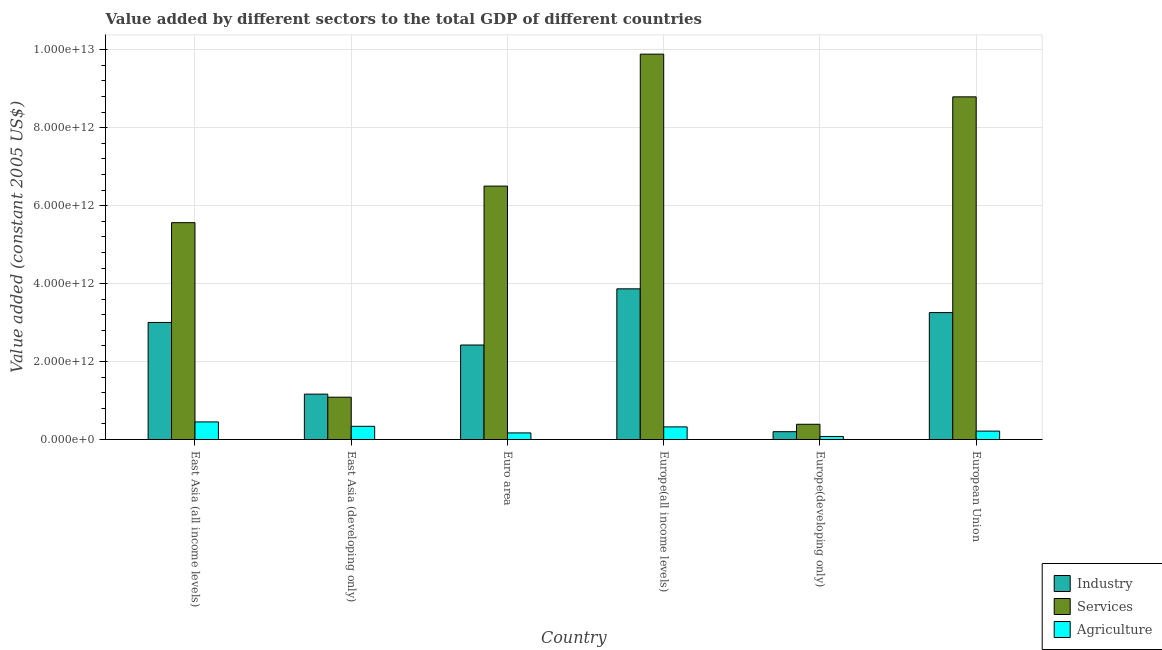How many different coloured bars are there?
Your response must be concise. 3. Are the number of bars on each tick of the X-axis equal?
Provide a succinct answer. Yes. How many bars are there on the 4th tick from the left?
Provide a succinct answer. 3. What is the label of the 5th group of bars from the left?
Give a very brief answer. Europe(developing only). What is the value added by industrial sector in Europe(developing only)?
Offer a terse response. 2.01e+11. Across all countries, what is the maximum value added by services?
Offer a terse response. 9.89e+12. Across all countries, what is the minimum value added by industrial sector?
Provide a succinct answer. 2.01e+11. In which country was the value added by industrial sector maximum?
Offer a very short reply. Europe(all income levels). In which country was the value added by agricultural sector minimum?
Provide a short and direct response. Europe(developing only). What is the total value added by industrial sector in the graph?
Offer a very short reply. 1.39e+13. What is the difference between the value added by agricultural sector in East Asia (all income levels) and that in European Union?
Provide a short and direct response. 2.35e+11. What is the difference between the value added by industrial sector in European Union and the value added by agricultural sector in East Asia (developing only)?
Offer a very short reply. 2.92e+12. What is the average value added by industrial sector per country?
Your answer should be compact. 2.32e+12. What is the difference between the value added by agricultural sector and value added by services in Europe(all income levels)?
Your response must be concise. -9.56e+12. In how many countries, is the value added by services greater than 7200000000000 US$?
Give a very brief answer. 2. What is the ratio of the value added by services in East Asia (developing only) to that in Euro area?
Your answer should be compact. 0.17. Is the value added by services in Euro area less than that in Europe(developing only)?
Your answer should be compact. No. Is the difference between the value added by services in Europe(developing only) and European Union greater than the difference between the value added by agricultural sector in Europe(developing only) and European Union?
Make the answer very short. No. What is the difference between the highest and the second highest value added by services?
Provide a short and direct response. 1.10e+12. What is the difference between the highest and the lowest value added by services?
Your answer should be very brief. 9.50e+12. Is the sum of the value added by services in East Asia (all income levels) and European Union greater than the maximum value added by industrial sector across all countries?
Offer a very short reply. Yes. What does the 3rd bar from the left in Europe(all income levels) represents?
Offer a very short reply. Agriculture. What does the 2nd bar from the right in Euro area represents?
Ensure brevity in your answer.  Services. How many bars are there?
Give a very brief answer. 18. How many countries are there in the graph?
Offer a terse response. 6. What is the difference between two consecutive major ticks on the Y-axis?
Ensure brevity in your answer.  2.00e+12. Does the graph contain grids?
Provide a short and direct response. Yes. How many legend labels are there?
Make the answer very short. 3. How are the legend labels stacked?
Offer a terse response. Vertical. What is the title of the graph?
Provide a succinct answer. Value added by different sectors to the total GDP of different countries. Does "Hydroelectric sources" appear as one of the legend labels in the graph?
Offer a very short reply. No. What is the label or title of the Y-axis?
Make the answer very short. Value added (constant 2005 US$). What is the Value added (constant 2005 US$) in Industry in East Asia (all income levels)?
Provide a short and direct response. 3.00e+12. What is the Value added (constant 2005 US$) of Services in East Asia (all income levels)?
Provide a succinct answer. 5.56e+12. What is the Value added (constant 2005 US$) in Agriculture in East Asia (all income levels)?
Provide a short and direct response. 4.52e+11. What is the Value added (constant 2005 US$) of Industry in East Asia (developing only)?
Provide a short and direct response. 1.16e+12. What is the Value added (constant 2005 US$) of Services in East Asia (developing only)?
Your response must be concise. 1.09e+12. What is the Value added (constant 2005 US$) of Agriculture in East Asia (developing only)?
Make the answer very short. 3.39e+11. What is the Value added (constant 2005 US$) of Industry in Euro area?
Provide a short and direct response. 2.42e+12. What is the Value added (constant 2005 US$) in Services in Euro area?
Offer a very short reply. 6.50e+12. What is the Value added (constant 2005 US$) in Agriculture in Euro area?
Your response must be concise. 1.69e+11. What is the Value added (constant 2005 US$) in Industry in Europe(all income levels)?
Provide a short and direct response. 3.87e+12. What is the Value added (constant 2005 US$) of Services in Europe(all income levels)?
Provide a succinct answer. 9.89e+12. What is the Value added (constant 2005 US$) of Agriculture in Europe(all income levels)?
Your response must be concise. 3.24e+11. What is the Value added (constant 2005 US$) of Industry in Europe(developing only)?
Offer a very short reply. 2.01e+11. What is the Value added (constant 2005 US$) in Services in Europe(developing only)?
Your response must be concise. 3.91e+11. What is the Value added (constant 2005 US$) in Agriculture in Europe(developing only)?
Your answer should be very brief. 7.79e+1. What is the Value added (constant 2005 US$) of Industry in European Union?
Provide a succinct answer. 3.26e+12. What is the Value added (constant 2005 US$) in Services in European Union?
Your response must be concise. 8.79e+12. What is the Value added (constant 2005 US$) of Agriculture in European Union?
Provide a short and direct response. 2.16e+11. Across all countries, what is the maximum Value added (constant 2005 US$) in Industry?
Your answer should be compact. 3.87e+12. Across all countries, what is the maximum Value added (constant 2005 US$) in Services?
Make the answer very short. 9.89e+12. Across all countries, what is the maximum Value added (constant 2005 US$) of Agriculture?
Give a very brief answer. 4.52e+11. Across all countries, what is the minimum Value added (constant 2005 US$) in Industry?
Provide a succinct answer. 2.01e+11. Across all countries, what is the minimum Value added (constant 2005 US$) of Services?
Keep it short and to the point. 3.91e+11. Across all countries, what is the minimum Value added (constant 2005 US$) of Agriculture?
Your response must be concise. 7.79e+1. What is the total Value added (constant 2005 US$) in Industry in the graph?
Provide a short and direct response. 1.39e+13. What is the total Value added (constant 2005 US$) in Services in the graph?
Your answer should be compact. 3.22e+13. What is the total Value added (constant 2005 US$) of Agriculture in the graph?
Provide a short and direct response. 1.58e+12. What is the difference between the Value added (constant 2005 US$) in Industry in East Asia (all income levels) and that in East Asia (developing only)?
Give a very brief answer. 1.84e+12. What is the difference between the Value added (constant 2005 US$) of Services in East Asia (all income levels) and that in East Asia (developing only)?
Offer a very short reply. 4.48e+12. What is the difference between the Value added (constant 2005 US$) in Agriculture in East Asia (all income levels) and that in East Asia (developing only)?
Your response must be concise. 1.13e+11. What is the difference between the Value added (constant 2005 US$) in Industry in East Asia (all income levels) and that in Euro area?
Provide a succinct answer. 5.79e+11. What is the difference between the Value added (constant 2005 US$) of Services in East Asia (all income levels) and that in Euro area?
Give a very brief answer. -9.38e+11. What is the difference between the Value added (constant 2005 US$) of Agriculture in East Asia (all income levels) and that in Euro area?
Your answer should be compact. 2.82e+11. What is the difference between the Value added (constant 2005 US$) in Industry in East Asia (all income levels) and that in Europe(all income levels)?
Provide a succinct answer. -8.63e+11. What is the difference between the Value added (constant 2005 US$) in Services in East Asia (all income levels) and that in Europe(all income levels)?
Your response must be concise. -4.32e+12. What is the difference between the Value added (constant 2005 US$) of Agriculture in East Asia (all income levels) and that in Europe(all income levels)?
Provide a short and direct response. 1.28e+11. What is the difference between the Value added (constant 2005 US$) of Industry in East Asia (all income levels) and that in Europe(developing only)?
Keep it short and to the point. 2.80e+12. What is the difference between the Value added (constant 2005 US$) of Services in East Asia (all income levels) and that in Europe(developing only)?
Your answer should be compact. 5.17e+12. What is the difference between the Value added (constant 2005 US$) in Agriculture in East Asia (all income levels) and that in Europe(developing only)?
Provide a short and direct response. 3.74e+11. What is the difference between the Value added (constant 2005 US$) in Industry in East Asia (all income levels) and that in European Union?
Give a very brief answer. -2.53e+11. What is the difference between the Value added (constant 2005 US$) in Services in East Asia (all income levels) and that in European Union?
Give a very brief answer. -3.23e+12. What is the difference between the Value added (constant 2005 US$) of Agriculture in East Asia (all income levels) and that in European Union?
Offer a terse response. 2.35e+11. What is the difference between the Value added (constant 2005 US$) in Industry in East Asia (developing only) and that in Euro area?
Offer a very short reply. -1.26e+12. What is the difference between the Value added (constant 2005 US$) of Services in East Asia (developing only) and that in Euro area?
Provide a short and direct response. -5.42e+12. What is the difference between the Value added (constant 2005 US$) in Agriculture in East Asia (developing only) and that in Euro area?
Your answer should be compact. 1.69e+11. What is the difference between the Value added (constant 2005 US$) of Industry in East Asia (developing only) and that in Europe(all income levels)?
Your response must be concise. -2.70e+12. What is the difference between the Value added (constant 2005 US$) in Services in East Asia (developing only) and that in Europe(all income levels)?
Keep it short and to the point. -8.80e+12. What is the difference between the Value added (constant 2005 US$) in Agriculture in East Asia (developing only) and that in Europe(all income levels)?
Make the answer very short. 1.49e+1. What is the difference between the Value added (constant 2005 US$) of Industry in East Asia (developing only) and that in Europe(developing only)?
Your answer should be compact. 9.63e+11. What is the difference between the Value added (constant 2005 US$) of Services in East Asia (developing only) and that in Europe(developing only)?
Your answer should be very brief. 6.95e+11. What is the difference between the Value added (constant 2005 US$) of Agriculture in East Asia (developing only) and that in Europe(developing only)?
Keep it short and to the point. 2.61e+11. What is the difference between the Value added (constant 2005 US$) in Industry in East Asia (developing only) and that in European Union?
Your response must be concise. -2.09e+12. What is the difference between the Value added (constant 2005 US$) in Services in East Asia (developing only) and that in European Union?
Offer a very short reply. -7.71e+12. What is the difference between the Value added (constant 2005 US$) of Agriculture in East Asia (developing only) and that in European Union?
Your answer should be very brief. 1.23e+11. What is the difference between the Value added (constant 2005 US$) in Industry in Euro area and that in Europe(all income levels)?
Offer a very short reply. -1.44e+12. What is the difference between the Value added (constant 2005 US$) in Services in Euro area and that in Europe(all income levels)?
Provide a short and direct response. -3.39e+12. What is the difference between the Value added (constant 2005 US$) in Agriculture in Euro area and that in Europe(all income levels)?
Offer a terse response. -1.54e+11. What is the difference between the Value added (constant 2005 US$) of Industry in Euro area and that in Europe(developing only)?
Your answer should be compact. 2.22e+12. What is the difference between the Value added (constant 2005 US$) of Services in Euro area and that in Europe(developing only)?
Make the answer very short. 6.11e+12. What is the difference between the Value added (constant 2005 US$) in Agriculture in Euro area and that in Europe(developing only)?
Your answer should be compact. 9.15e+1. What is the difference between the Value added (constant 2005 US$) of Industry in Euro area and that in European Union?
Offer a terse response. -8.32e+11. What is the difference between the Value added (constant 2005 US$) of Services in Euro area and that in European Union?
Offer a very short reply. -2.29e+12. What is the difference between the Value added (constant 2005 US$) of Agriculture in Euro area and that in European Union?
Your answer should be very brief. -4.67e+1. What is the difference between the Value added (constant 2005 US$) of Industry in Europe(all income levels) and that in Europe(developing only)?
Offer a terse response. 3.67e+12. What is the difference between the Value added (constant 2005 US$) of Services in Europe(all income levels) and that in Europe(developing only)?
Ensure brevity in your answer.  9.50e+12. What is the difference between the Value added (constant 2005 US$) of Agriculture in Europe(all income levels) and that in Europe(developing only)?
Provide a succinct answer. 2.46e+11. What is the difference between the Value added (constant 2005 US$) of Industry in Europe(all income levels) and that in European Union?
Provide a succinct answer. 6.09e+11. What is the difference between the Value added (constant 2005 US$) of Services in Europe(all income levels) and that in European Union?
Keep it short and to the point. 1.10e+12. What is the difference between the Value added (constant 2005 US$) in Agriculture in Europe(all income levels) and that in European Union?
Keep it short and to the point. 1.08e+11. What is the difference between the Value added (constant 2005 US$) of Industry in Europe(developing only) and that in European Union?
Keep it short and to the point. -3.06e+12. What is the difference between the Value added (constant 2005 US$) in Services in Europe(developing only) and that in European Union?
Your answer should be very brief. -8.40e+12. What is the difference between the Value added (constant 2005 US$) in Agriculture in Europe(developing only) and that in European Union?
Your response must be concise. -1.38e+11. What is the difference between the Value added (constant 2005 US$) in Industry in East Asia (all income levels) and the Value added (constant 2005 US$) in Services in East Asia (developing only)?
Offer a very short reply. 1.92e+12. What is the difference between the Value added (constant 2005 US$) in Industry in East Asia (all income levels) and the Value added (constant 2005 US$) in Agriculture in East Asia (developing only)?
Your response must be concise. 2.67e+12. What is the difference between the Value added (constant 2005 US$) of Services in East Asia (all income levels) and the Value added (constant 2005 US$) of Agriculture in East Asia (developing only)?
Your answer should be compact. 5.23e+12. What is the difference between the Value added (constant 2005 US$) of Industry in East Asia (all income levels) and the Value added (constant 2005 US$) of Services in Euro area?
Ensure brevity in your answer.  -3.50e+12. What is the difference between the Value added (constant 2005 US$) of Industry in East Asia (all income levels) and the Value added (constant 2005 US$) of Agriculture in Euro area?
Make the answer very short. 2.83e+12. What is the difference between the Value added (constant 2005 US$) of Services in East Asia (all income levels) and the Value added (constant 2005 US$) of Agriculture in Euro area?
Offer a very short reply. 5.39e+12. What is the difference between the Value added (constant 2005 US$) of Industry in East Asia (all income levels) and the Value added (constant 2005 US$) of Services in Europe(all income levels)?
Make the answer very short. -6.88e+12. What is the difference between the Value added (constant 2005 US$) of Industry in East Asia (all income levels) and the Value added (constant 2005 US$) of Agriculture in Europe(all income levels)?
Keep it short and to the point. 2.68e+12. What is the difference between the Value added (constant 2005 US$) of Services in East Asia (all income levels) and the Value added (constant 2005 US$) of Agriculture in Europe(all income levels)?
Your answer should be compact. 5.24e+12. What is the difference between the Value added (constant 2005 US$) in Industry in East Asia (all income levels) and the Value added (constant 2005 US$) in Services in Europe(developing only)?
Your answer should be very brief. 2.61e+12. What is the difference between the Value added (constant 2005 US$) of Industry in East Asia (all income levels) and the Value added (constant 2005 US$) of Agriculture in Europe(developing only)?
Provide a short and direct response. 2.93e+12. What is the difference between the Value added (constant 2005 US$) of Services in East Asia (all income levels) and the Value added (constant 2005 US$) of Agriculture in Europe(developing only)?
Provide a succinct answer. 5.49e+12. What is the difference between the Value added (constant 2005 US$) in Industry in East Asia (all income levels) and the Value added (constant 2005 US$) in Services in European Union?
Give a very brief answer. -5.79e+12. What is the difference between the Value added (constant 2005 US$) of Industry in East Asia (all income levels) and the Value added (constant 2005 US$) of Agriculture in European Union?
Ensure brevity in your answer.  2.79e+12. What is the difference between the Value added (constant 2005 US$) of Services in East Asia (all income levels) and the Value added (constant 2005 US$) of Agriculture in European Union?
Your answer should be very brief. 5.35e+12. What is the difference between the Value added (constant 2005 US$) of Industry in East Asia (developing only) and the Value added (constant 2005 US$) of Services in Euro area?
Offer a terse response. -5.34e+12. What is the difference between the Value added (constant 2005 US$) in Industry in East Asia (developing only) and the Value added (constant 2005 US$) in Agriculture in Euro area?
Provide a short and direct response. 9.95e+11. What is the difference between the Value added (constant 2005 US$) in Services in East Asia (developing only) and the Value added (constant 2005 US$) in Agriculture in Euro area?
Keep it short and to the point. 9.16e+11. What is the difference between the Value added (constant 2005 US$) in Industry in East Asia (developing only) and the Value added (constant 2005 US$) in Services in Europe(all income levels)?
Ensure brevity in your answer.  -8.72e+12. What is the difference between the Value added (constant 2005 US$) of Industry in East Asia (developing only) and the Value added (constant 2005 US$) of Agriculture in Europe(all income levels)?
Your response must be concise. 8.40e+11. What is the difference between the Value added (constant 2005 US$) of Services in East Asia (developing only) and the Value added (constant 2005 US$) of Agriculture in Europe(all income levels)?
Keep it short and to the point. 7.62e+11. What is the difference between the Value added (constant 2005 US$) in Industry in East Asia (developing only) and the Value added (constant 2005 US$) in Services in Europe(developing only)?
Your answer should be very brief. 7.73e+11. What is the difference between the Value added (constant 2005 US$) in Industry in East Asia (developing only) and the Value added (constant 2005 US$) in Agriculture in Europe(developing only)?
Your answer should be very brief. 1.09e+12. What is the difference between the Value added (constant 2005 US$) in Services in East Asia (developing only) and the Value added (constant 2005 US$) in Agriculture in Europe(developing only)?
Offer a very short reply. 1.01e+12. What is the difference between the Value added (constant 2005 US$) of Industry in East Asia (developing only) and the Value added (constant 2005 US$) of Services in European Union?
Ensure brevity in your answer.  -7.63e+12. What is the difference between the Value added (constant 2005 US$) in Industry in East Asia (developing only) and the Value added (constant 2005 US$) in Agriculture in European Union?
Ensure brevity in your answer.  9.48e+11. What is the difference between the Value added (constant 2005 US$) in Services in East Asia (developing only) and the Value added (constant 2005 US$) in Agriculture in European Union?
Ensure brevity in your answer.  8.70e+11. What is the difference between the Value added (constant 2005 US$) of Industry in Euro area and the Value added (constant 2005 US$) of Services in Europe(all income levels)?
Make the answer very short. -7.46e+12. What is the difference between the Value added (constant 2005 US$) in Industry in Euro area and the Value added (constant 2005 US$) in Agriculture in Europe(all income levels)?
Your answer should be compact. 2.10e+12. What is the difference between the Value added (constant 2005 US$) in Services in Euro area and the Value added (constant 2005 US$) in Agriculture in Europe(all income levels)?
Your answer should be very brief. 6.18e+12. What is the difference between the Value added (constant 2005 US$) of Industry in Euro area and the Value added (constant 2005 US$) of Services in Europe(developing only)?
Make the answer very short. 2.03e+12. What is the difference between the Value added (constant 2005 US$) in Industry in Euro area and the Value added (constant 2005 US$) in Agriculture in Europe(developing only)?
Your response must be concise. 2.35e+12. What is the difference between the Value added (constant 2005 US$) in Services in Euro area and the Value added (constant 2005 US$) in Agriculture in Europe(developing only)?
Ensure brevity in your answer.  6.42e+12. What is the difference between the Value added (constant 2005 US$) in Industry in Euro area and the Value added (constant 2005 US$) in Services in European Union?
Provide a succinct answer. -6.37e+12. What is the difference between the Value added (constant 2005 US$) of Industry in Euro area and the Value added (constant 2005 US$) of Agriculture in European Union?
Offer a very short reply. 2.21e+12. What is the difference between the Value added (constant 2005 US$) of Services in Euro area and the Value added (constant 2005 US$) of Agriculture in European Union?
Ensure brevity in your answer.  6.29e+12. What is the difference between the Value added (constant 2005 US$) of Industry in Europe(all income levels) and the Value added (constant 2005 US$) of Services in Europe(developing only)?
Keep it short and to the point. 3.47e+12. What is the difference between the Value added (constant 2005 US$) in Industry in Europe(all income levels) and the Value added (constant 2005 US$) in Agriculture in Europe(developing only)?
Your answer should be very brief. 3.79e+12. What is the difference between the Value added (constant 2005 US$) of Services in Europe(all income levels) and the Value added (constant 2005 US$) of Agriculture in Europe(developing only)?
Keep it short and to the point. 9.81e+12. What is the difference between the Value added (constant 2005 US$) of Industry in Europe(all income levels) and the Value added (constant 2005 US$) of Services in European Union?
Offer a very short reply. -4.93e+12. What is the difference between the Value added (constant 2005 US$) in Industry in Europe(all income levels) and the Value added (constant 2005 US$) in Agriculture in European Union?
Make the answer very short. 3.65e+12. What is the difference between the Value added (constant 2005 US$) of Services in Europe(all income levels) and the Value added (constant 2005 US$) of Agriculture in European Union?
Offer a terse response. 9.67e+12. What is the difference between the Value added (constant 2005 US$) of Industry in Europe(developing only) and the Value added (constant 2005 US$) of Services in European Union?
Provide a succinct answer. -8.59e+12. What is the difference between the Value added (constant 2005 US$) in Industry in Europe(developing only) and the Value added (constant 2005 US$) in Agriculture in European Union?
Keep it short and to the point. -1.51e+1. What is the difference between the Value added (constant 2005 US$) in Services in Europe(developing only) and the Value added (constant 2005 US$) in Agriculture in European Union?
Offer a very short reply. 1.75e+11. What is the average Value added (constant 2005 US$) of Industry per country?
Provide a short and direct response. 2.32e+12. What is the average Value added (constant 2005 US$) in Services per country?
Offer a terse response. 5.37e+12. What is the average Value added (constant 2005 US$) of Agriculture per country?
Your answer should be compact. 2.63e+11. What is the difference between the Value added (constant 2005 US$) in Industry and Value added (constant 2005 US$) in Services in East Asia (all income levels)?
Offer a terse response. -2.56e+12. What is the difference between the Value added (constant 2005 US$) of Industry and Value added (constant 2005 US$) of Agriculture in East Asia (all income levels)?
Your answer should be compact. 2.55e+12. What is the difference between the Value added (constant 2005 US$) in Services and Value added (constant 2005 US$) in Agriculture in East Asia (all income levels)?
Your answer should be very brief. 5.11e+12. What is the difference between the Value added (constant 2005 US$) in Industry and Value added (constant 2005 US$) in Services in East Asia (developing only)?
Provide a succinct answer. 7.85e+1. What is the difference between the Value added (constant 2005 US$) in Industry and Value added (constant 2005 US$) in Agriculture in East Asia (developing only)?
Give a very brief answer. 8.26e+11. What is the difference between the Value added (constant 2005 US$) in Services and Value added (constant 2005 US$) in Agriculture in East Asia (developing only)?
Provide a succinct answer. 7.47e+11. What is the difference between the Value added (constant 2005 US$) in Industry and Value added (constant 2005 US$) in Services in Euro area?
Give a very brief answer. -4.08e+12. What is the difference between the Value added (constant 2005 US$) of Industry and Value added (constant 2005 US$) of Agriculture in Euro area?
Keep it short and to the point. 2.26e+12. What is the difference between the Value added (constant 2005 US$) of Services and Value added (constant 2005 US$) of Agriculture in Euro area?
Your response must be concise. 6.33e+12. What is the difference between the Value added (constant 2005 US$) of Industry and Value added (constant 2005 US$) of Services in Europe(all income levels)?
Ensure brevity in your answer.  -6.02e+12. What is the difference between the Value added (constant 2005 US$) in Industry and Value added (constant 2005 US$) in Agriculture in Europe(all income levels)?
Make the answer very short. 3.54e+12. What is the difference between the Value added (constant 2005 US$) of Services and Value added (constant 2005 US$) of Agriculture in Europe(all income levels)?
Keep it short and to the point. 9.56e+12. What is the difference between the Value added (constant 2005 US$) in Industry and Value added (constant 2005 US$) in Services in Europe(developing only)?
Your answer should be very brief. -1.90e+11. What is the difference between the Value added (constant 2005 US$) in Industry and Value added (constant 2005 US$) in Agriculture in Europe(developing only)?
Give a very brief answer. 1.23e+11. What is the difference between the Value added (constant 2005 US$) of Services and Value added (constant 2005 US$) of Agriculture in Europe(developing only)?
Offer a very short reply. 3.13e+11. What is the difference between the Value added (constant 2005 US$) of Industry and Value added (constant 2005 US$) of Services in European Union?
Your answer should be compact. -5.53e+12. What is the difference between the Value added (constant 2005 US$) in Industry and Value added (constant 2005 US$) in Agriculture in European Union?
Make the answer very short. 3.04e+12. What is the difference between the Value added (constant 2005 US$) of Services and Value added (constant 2005 US$) of Agriculture in European Union?
Provide a succinct answer. 8.58e+12. What is the ratio of the Value added (constant 2005 US$) in Industry in East Asia (all income levels) to that in East Asia (developing only)?
Ensure brevity in your answer.  2.58. What is the ratio of the Value added (constant 2005 US$) in Services in East Asia (all income levels) to that in East Asia (developing only)?
Your response must be concise. 5.12. What is the ratio of the Value added (constant 2005 US$) of Agriculture in East Asia (all income levels) to that in East Asia (developing only)?
Your answer should be compact. 1.33. What is the ratio of the Value added (constant 2005 US$) of Industry in East Asia (all income levels) to that in Euro area?
Your answer should be compact. 1.24. What is the ratio of the Value added (constant 2005 US$) in Services in East Asia (all income levels) to that in Euro area?
Ensure brevity in your answer.  0.86. What is the ratio of the Value added (constant 2005 US$) in Agriculture in East Asia (all income levels) to that in Euro area?
Your answer should be very brief. 2.67. What is the ratio of the Value added (constant 2005 US$) of Industry in East Asia (all income levels) to that in Europe(all income levels)?
Ensure brevity in your answer.  0.78. What is the ratio of the Value added (constant 2005 US$) in Services in East Asia (all income levels) to that in Europe(all income levels)?
Provide a short and direct response. 0.56. What is the ratio of the Value added (constant 2005 US$) in Agriculture in East Asia (all income levels) to that in Europe(all income levels)?
Provide a short and direct response. 1.39. What is the ratio of the Value added (constant 2005 US$) of Industry in East Asia (all income levels) to that in Europe(developing only)?
Keep it short and to the point. 14.94. What is the ratio of the Value added (constant 2005 US$) of Services in East Asia (all income levels) to that in Europe(developing only)?
Offer a terse response. 14.22. What is the ratio of the Value added (constant 2005 US$) in Agriculture in East Asia (all income levels) to that in Europe(developing only)?
Keep it short and to the point. 5.8. What is the ratio of the Value added (constant 2005 US$) of Industry in East Asia (all income levels) to that in European Union?
Keep it short and to the point. 0.92. What is the ratio of the Value added (constant 2005 US$) of Services in East Asia (all income levels) to that in European Union?
Provide a short and direct response. 0.63. What is the ratio of the Value added (constant 2005 US$) in Agriculture in East Asia (all income levels) to that in European Union?
Give a very brief answer. 2.09. What is the ratio of the Value added (constant 2005 US$) of Industry in East Asia (developing only) to that in Euro area?
Provide a short and direct response. 0.48. What is the ratio of the Value added (constant 2005 US$) of Services in East Asia (developing only) to that in Euro area?
Your response must be concise. 0.17. What is the ratio of the Value added (constant 2005 US$) in Agriculture in East Asia (developing only) to that in Euro area?
Provide a short and direct response. 2. What is the ratio of the Value added (constant 2005 US$) in Industry in East Asia (developing only) to that in Europe(all income levels)?
Your answer should be very brief. 0.3. What is the ratio of the Value added (constant 2005 US$) in Services in East Asia (developing only) to that in Europe(all income levels)?
Provide a short and direct response. 0.11. What is the ratio of the Value added (constant 2005 US$) in Agriculture in East Asia (developing only) to that in Europe(all income levels)?
Your answer should be compact. 1.05. What is the ratio of the Value added (constant 2005 US$) in Industry in East Asia (developing only) to that in Europe(developing only)?
Keep it short and to the point. 5.79. What is the ratio of the Value added (constant 2005 US$) in Services in East Asia (developing only) to that in Europe(developing only)?
Your answer should be very brief. 2.78. What is the ratio of the Value added (constant 2005 US$) of Agriculture in East Asia (developing only) to that in Europe(developing only)?
Provide a short and direct response. 4.35. What is the ratio of the Value added (constant 2005 US$) in Industry in East Asia (developing only) to that in European Union?
Offer a terse response. 0.36. What is the ratio of the Value added (constant 2005 US$) of Services in East Asia (developing only) to that in European Union?
Ensure brevity in your answer.  0.12. What is the ratio of the Value added (constant 2005 US$) in Agriculture in East Asia (developing only) to that in European Union?
Provide a succinct answer. 1.57. What is the ratio of the Value added (constant 2005 US$) of Industry in Euro area to that in Europe(all income levels)?
Provide a succinct answer. 0.63. What is the ratio of the Value added (constant 2005 US$) of Services in Euro area to that in Europe(all income levels)?
Give a very brief answer. 0.66. What is the ratio of the Value added (constant 2005 US$) of Agriculture in Euro area to that in Europe(all income levels)?
Give a very brief answer. 0.52. What is the ratio of the Value added (constant 2005 US$) in Industry in Euro area to that in Europe(developing only)?
Your answer should be compact. 12.06. What is the ratio of the Value added (constant 2005 US$) of Services in Euro area to that in Europe(developing only)?
Your answer should be compact. 16.62. What is the ratio of the Value added (constant 2005 US$) of Agriculture in Euro area to that in Europe(developing only)?
Offer a very short reply. 2.17. What is the ratio of the Value added (constant 2005 US$) in Industry in Euro area to that in European Union?
Your answer should be compact. 0.74. What is the ratio of the Value added (constant 2005 US$) in Services in Euro area to that in European Union?
Make the answer very short. 0.74. What is the ratio of the Value added (constant 2005 US$) in Agriculture in Euro area to that in European Union?
Provide a succinct answer. 0.78. What is the ratio of the Value added (constant 2005 US$) in Industry in Europe(all income levels) to that in Europe(developing only)?
Give a very brief answer. 19.23. What is the ratio of the Value added (constant 2005 US$) in Services in Europe(all income levels) to that in Europe(developing only)?
Ensure brevity in your answer.  25.27. What is the ratio of the Value added (constant 2005 US$) in Agriculture in Europe(all income levels) to that in Europe(developing only)?
Your response must be concise. 4.16. What is the ratio of the Value added (constant 2005 US$) of Industry in Europe(all income levels) to that in European Union?
Offer a terse response. 1.19. What is the ratio of the Value added (constant 2005 US$) of Services in Europe(all income levels) to that in European Union?
Keep it short and to the point. 1.12. What is the ratio of the Value added (constant 2005 US$) of Agriculture in Europe(all income levels) to that in European Union?
Offer a terse response. 1.5. What is the ratio of the Value added (constant 2005 US$) in Industry in Europe(developing only) to that in European Union?
Provide a short and direct response. 0.06. What is the ratio of the Value added (constant 2005 US$) in Services in Europe(developing only) to that in European Union?
Offer a terse response. 0.04. What is the ratio of the Value added (constant 2005 US$) in Agriculture in Europe(developing only) to that in European Union?
Your answer should be very brief. 0.36. What is the difference between the highest and the second highest Value added (constant 2005 US$) in Industry?
Offer a terse response. 6.09e+11. What is the difference between the highest and the second highest Value added (constant 2005 US$) of Services?
Keep it short and to the point. 1.10e+12. What is the difference between the highest and the second highest Value added (constant 2005 US$) in Agriculture?
Give a very brief answer. 1.13e+11. What is the difference between the highest and the lowest Value added (constant 2005 US$) of Industry?
Make the answer very short. 3.67e+12. What is the difference between the highest and the lowest Value added (constant 2005 US$) in Services?
Provide a short and direct response. 9.50e+12. What is the difference between the highest and the lowest Value added (constant 2005 US$) in Agriculture?
Your answer should be compact. 3.74e+11. 